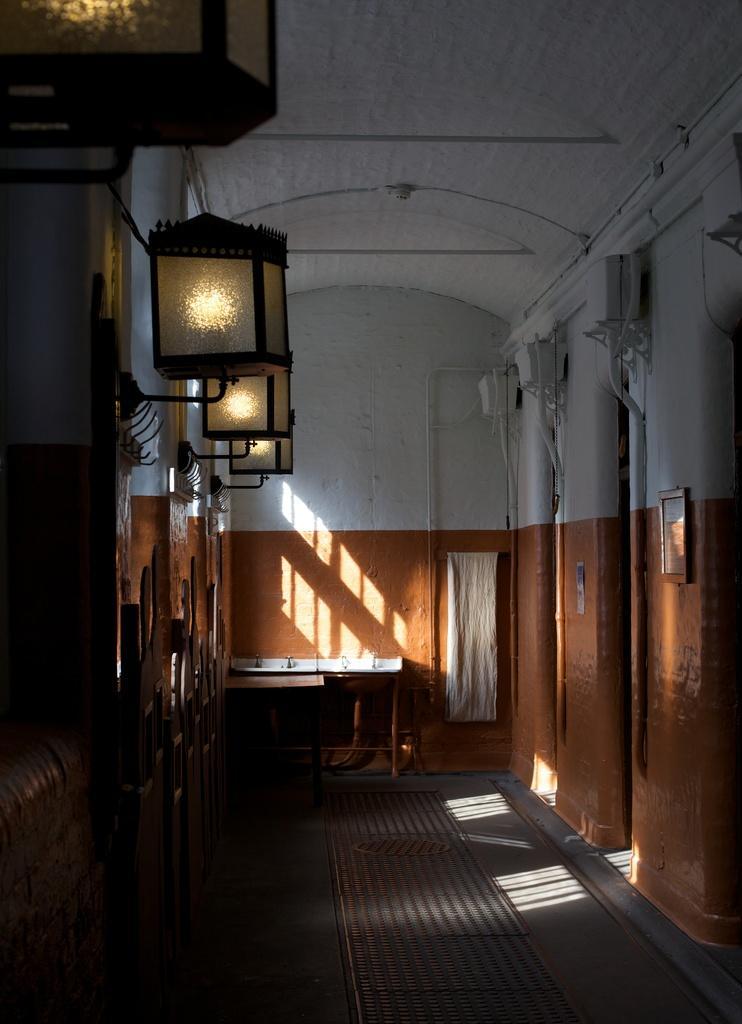Please provide a concise description of this image. In this image there is a path, on the left side and right side, there are wall, on the left side there are lights, in the background there is a wall to that wall there is a sink. 